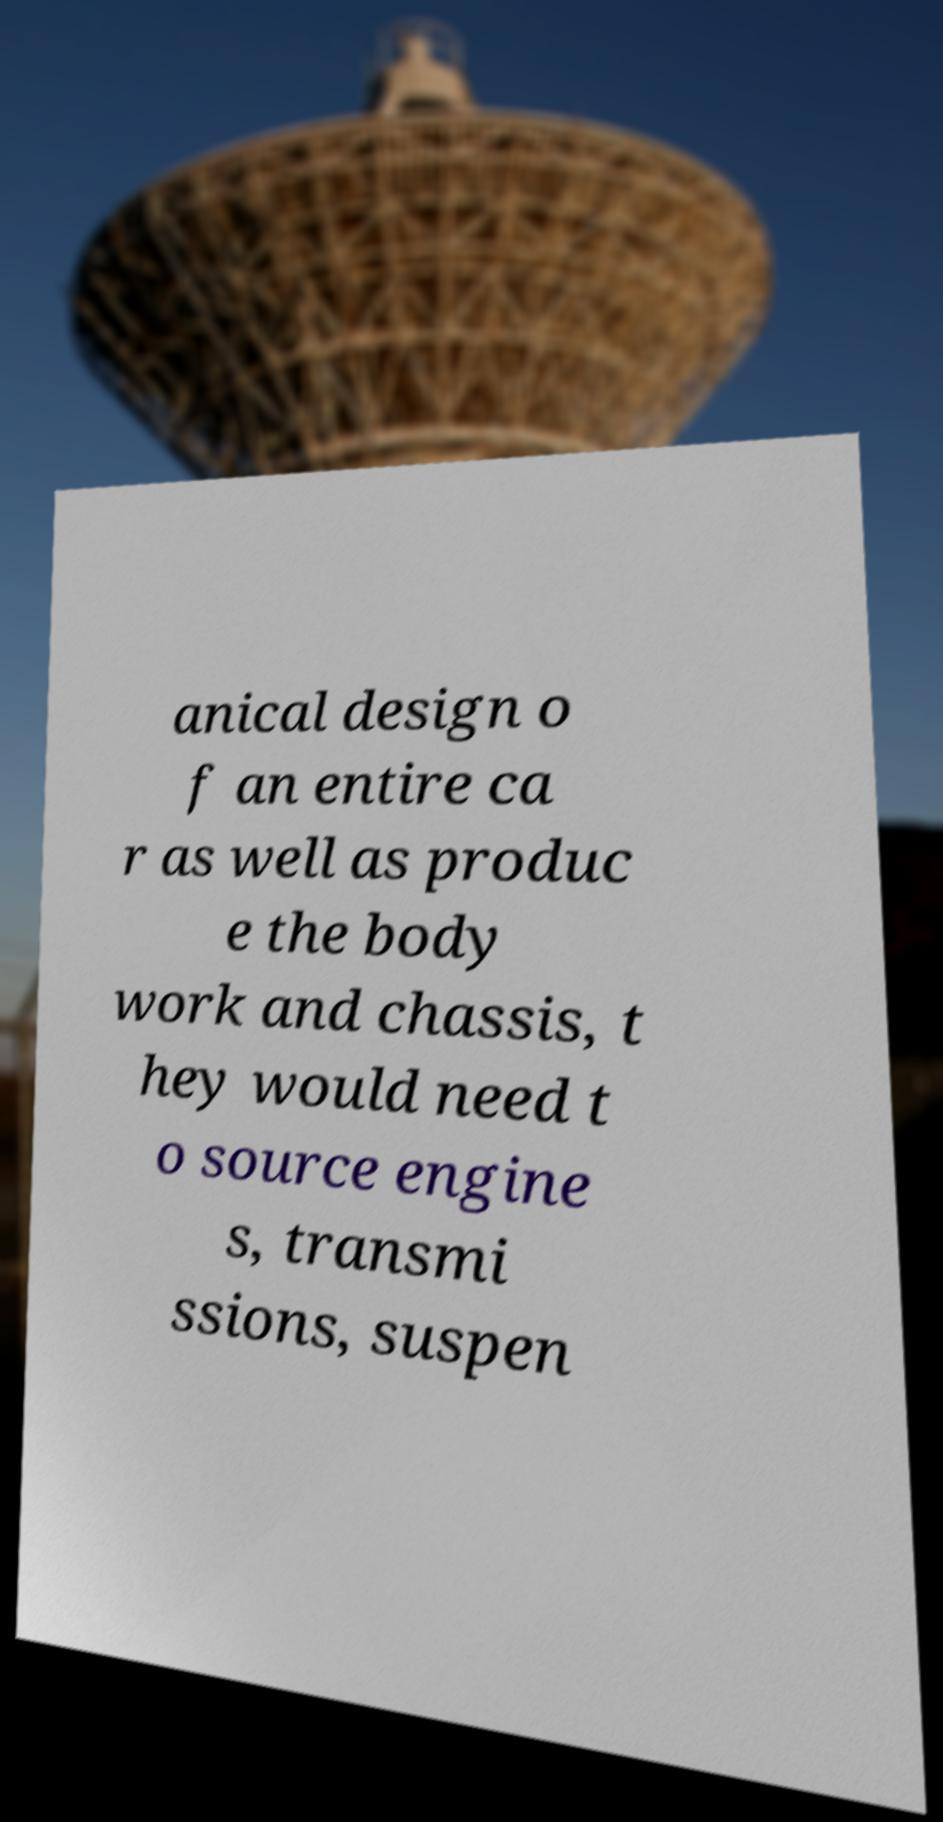What messages or text are displayed in this image? I need them in a readable, typed format. anical design o f an entire ca r as well as produc e the body work and chassis, t hey would need t o source engine s, transmi ssions, suspen 